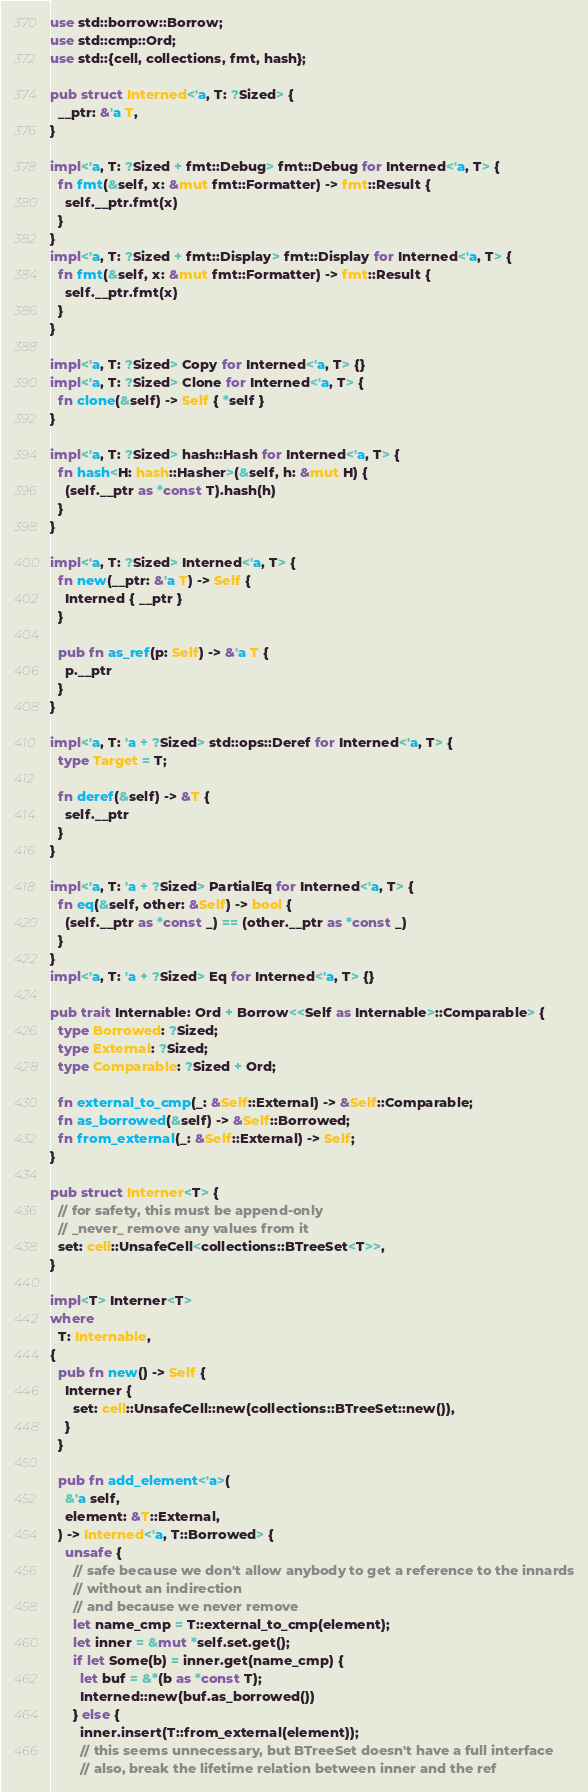<code> <loc_0><loc_0><loc_500><loc_500><_Rust_>use std::borrow::Borrow;
use std::cmp::Ord;
use std::{cell, collections, fmt, hash};

pub struct Interned<'a, T: ?Sized> {
  __ptr: &'a T,
}

impl<'a, T: ?Sized + fmt::Debug> fmt::Debug for Interned<'a, T> {
  fn fmt(&self, x: &mut fmt::Formatter) -> fmt::Result {
    self.__ptr.fmt(x)
  }
}
impl<'a, T: ?Sized + fmt::Display> fmt::Display for Interned<'a, T> {
  fn fmt(&self, x: &mut fmt::Formatter) -> fmt::Result {
    self.__ptr.fmt(x)
  }
}

impl<'a, T: ?Sized> Copy for Interned<'a, T> {}
impl<'a, T: ?Sized> Clone for Interned<'a, T> {
  fn clone(&self) -> Self { *self }
}

impl<'a, T: ?Sized> hash::Hash for Interned<'a, T> {
  fn hash<H: hash::Hasher>(&self, h: &mut H) {
    (self.__ptr as *const T).hash(h)
  }
}

impl<'a, T: ?Sized> Interned<'a, T> {
  fn new(__ptr: &'a T) -> Self {
    Interned { __ptr }
  }

  pub fn as_ref(p: Self) -> &'a T {
    p.__ptr
  }
}

impl<'a, T: 'a + ?Sized> std::ops::Deref for Interned<'a, T> {
  type Target = T;

  fn deref(&self) -> &T {
    self.__ptr
  }
}

impl<'a, T: 'a + ?Sized> PartialEq for Interned<'a, T> {
  fn eq(&self, other: &Self) -> bool {
    (self.__ptr as *const _) == (other.__ptr as *const _)
  }
}
impl<'a, T: 'a + ?Sized> Eq for Interned<'a, T> {}

pub trait Internable: Ord + Borrow<<Self as Internable>::Comparable> {
  type Borrowed: ?Sized;
  type External: ?Sized;
  type Comparable: ?Sized + Ord;

  fn external_to_cmp(_: &Self::External) -> &Self::Comparable;
  fn as_borrowed(&self) -> &Self::Borrowed;
  fn from_external(_: &Self::External) -> Self;
}

pub struct Interner<T> {
  // for safety, this must be append-only
  // _never_ remove any values from it
  set: cell::UnsafeCell<collections::BTreeSet<T>>,
}

impl<T> Interner<T>
where
  T: Internable,
{
  pub fn new() -> Self {
    Interner {
      set: cell::UnsafeCell::new(collections::BTreeSet::new()),
    }
  }

  pub fn add_element<'a>(
    &'a self,
    element: &T::External,
  ) -> Interned<'a, T::Borrowed> {
    unsafe {
      // safe because we don't allow anybody to get a reference to the innards
      // without an indirection
      // and because we never remove
      let name_cmp = T::external_to_cmp(element);
      let inner = &mut *self.set.get();
      if let Some(b) = inner.get(name_cmp) {
        let buf = &*(b as *const T);
        Interned::new(buf.as_borrowed())
      } else {
        inner.insert(T::from_external(element));
        // this seems unnecessary, but BTreeSet doesn't have a full interface
        // also, break the lifetime relation between inner and the ref</code> 